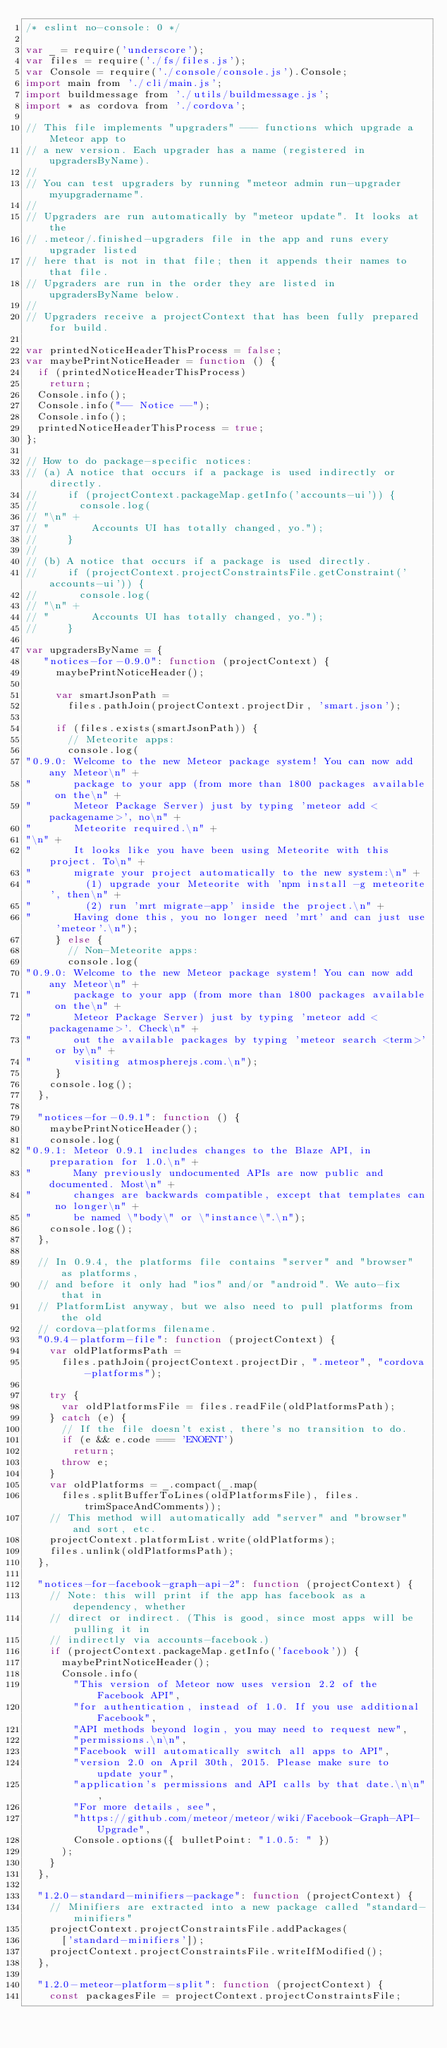Convert code to text. <code><loc_0><loc_0><loc_500><loc_500><_JavaScript_>/* eslint no-console: 0 */

var _ = require('underscore');
var files = require('./fs/files.js');
var Console = require('./console/console.js').Console;
import main from './cli/main.js';
import buildmessage from './utils/buildmessage.js';
import * as cordova from './cordova';

// This file implements "upgraders" --- functions which upgrade a Meteor app to
// a new version. Each upgrader has a name (registered in upgradersByName).
//
// You can test upgraders by running "meteor admin run-upgrader myupgradername".
//
// Upgraders are run automatically by "meteor update". It looks at the
// .meteor/.finished-upgraders file in the app and runs every upgrader listed
// here that is not in that file; then it appends their names to that file.
// Upgraders are run in the order they are listed in upgradersByName below.
//
// Upgraders receive a projectContext that has been fully prepared for build.

var printedNoticeHeaderThisProcess = false;
var maybePrintNoticeHeader = function () {
  if (printedNoticeHeaderThisProcess)
    return;
  Console.info();
  Console.info("-- Notice --");
  Console.info();
  printedNoticeHeaderThisProcess = true;
};

// How to do package-specific notices:
// (a) A notice that occurs if a package is used indirectly or directly.
//     if (projectContext.packageMap.getInfo('accounts-ui')) {
//       console.log(
// "\n" +
// "       Accounts UI has totally changed, yo.");
//     }
//
// (b) A notice that occurs if a package is used directly.
//     if (projectContext.projectConstraintsFile.getConstraint('accounts-ui')) {
//       console.log(
// "\n" +
// "       Accounts UI has totally changed, yo.");
//     }

var upgradersByName = {
   "notices-for-0.9.0": function (projectContext) {
     maybePrintNoticeHeader();

     var smartJsonPath =
       files.pathJoin(projectContext.projectDir, 'smart.json');

     if (files.exists(smartJsonPath)) {
       // Meteorite apps:
       console.log(
"0.9.0: Welcome to the new Meteor package system! You can now add any Meteor\n" +
"       package to your app (from more than 1800 packages available on the\n" +
"       Meteor Package Server) just by typing 'meteor add <packagename>', no\n" +
"       Meteorite required.\n" +
"\n" +
"       It looks like you have been using Meteorite with this project. To\n" +
"       migrate your project automatically to the new system:\n" +
"         (1) upgrade your Meteorite with 'npm install -g meteorite', then\n" +
"         (2) run 'mrt migrate-app' inside the project.\n" +
"       Having done this, you no longer need 'mrt' and can just use 'meteor'.\n");
     } else {
       // Non-Meteorite apps:
       console.log(
"0.9.0: Welcome to the new Meteor package system! You can now add any Meteor\n" +
"       package to your app (from more than 1800 packages available on the\n" +
"       Meteor Package Server) just by typing 'meteor add <packagename>'. Check\n" +
"       out the available packages by typing 'meteor search <term>' or by\n" +
"       visiting atmospherejs.com.\n");
     }
    console.log();
  },

  "notices-for-0.9.1": function () {
    maybePrintNoticeHeader();
    console.log(
"0.9.1: Meteor 0.9.1 includes changes to the Blaze API, in preparation for 1.0.\n" +
"       Many previously undocumented APIs are now public and documented. Most\n" +
"       changes are backwards compatible, except that templates can no longer\n" +
"       be named \"body\" or \"instance\".\n");
    console.log();
  },

  // In 0.9.4, the platforms file contains "server" and "browser" as platforms,
  // and before it only had "ios" and/or "android". We auto-fix that in
  // PlatformList anyway, but we also need to pull platforms from the old
  // cordova-platforms filename.
  "0.9.4-platform-file": function (projectContext) {
    var oldPlatformsPath =
      files.pathJoin(projectContext.projectDir, ".meteor", "cordova-platforms");

    try {
      var oldPlatformsFile = files.readFile(oldPlatformsPath);
    } catch (e) {
      // If the file doesn't exist, there's no transition to do.
      if (e && e.code === 'ENOENT')
        return;
      throw e;
    }
    var oldPlatforms = _.compact(_.map(
      files.splitBufferToLines(oldPlatformsFile), files.trimSpaceAndComments));
    // This method will automatically add "server" and "browser" and sort, etc.
    projectContext.platformList.write(oldPlatforms);
    files.unlink(oldPlatformsPath);
  },

  "notices-for-facebook-graph-api-2": function (projectContext) {
    // Note: this will print if the app has facebook as a dependency, whether
    // direct or indirect. (This is good, since most apps will be pulling it in
    // indirectly via accounts-facebook.)
    if (projectContext.packageMap.getInfo('facebook')) {
      maybePrintNoticeHeader();
      Console.info(
        "This version of Meteor now uses version 2.2 of the Facebook API",
        "for authentication, instead of 1.0. If you use additional Facebook",
        "API methods beyond login, you may need to request new",
        "permissions.\n\n",
        "Facebook will automatically switch all apps to API",
        "version 2.0 on April 30th, 2015. Please make sure to update your",
        "application's permissions and API calls by that date.\n\n",
        "For more details, see",
        "https://github.com/meteor/meteor/wiki/Facebook-Graph-API-Upgrade",
        Console.options({ bulletPoint: "1.0.5: " })
      );
    }
  },

  "1.2.0-standard-minifiers-package": function (projectContext) {
    // Minifiers are extracted into a new package called "standard-minifiers"
    projectContext.projectConstraintsFile.addPackages(
      ['standard-minifiers']);
    projectContext.projectConstraintsFile.writeIfModified();
  },

  "1.2.0-meteor-platform-split": function (projectContext) {
    const packagesFile = projectContext.projectConstraintsFile;</code> 